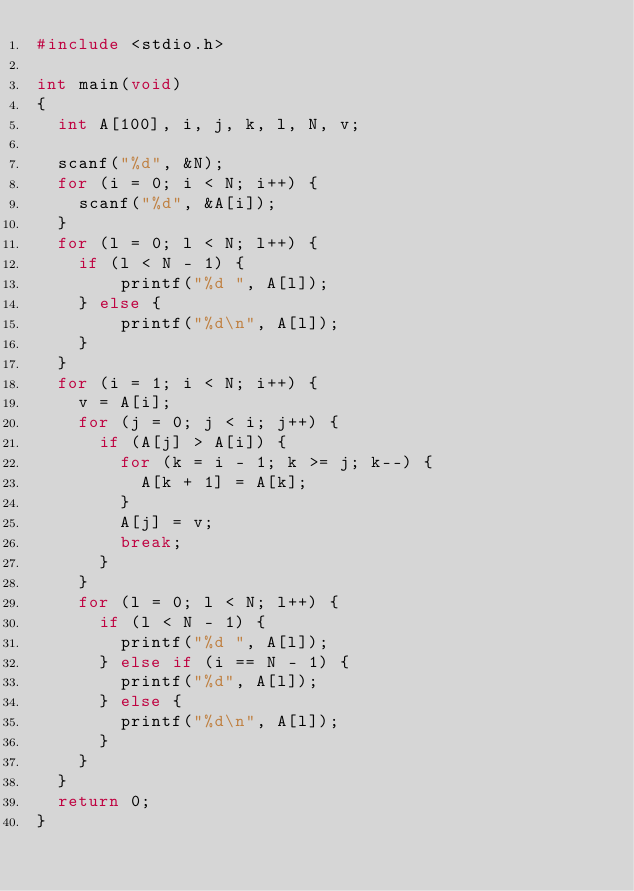Convert code to text. <code><loc_0><loc_0><loc_500><loc_500><_C_>#include <stdio.h>

int main(void)
{
	int A[100], i, j, k, l, N, v;
	
	scanf("%d", &N);
	for (i = 0; i < N; i++) {
		scanf("%d", &A[i]);
	}
	for (l = 0; l < N; l++) {
		if (l < N - 1) {
				printf("%d ", A[l]);
		} else {
				printf("%d\n", A[l]);
		}
	}
	for (i = 1; i < N; i++) {
		v = A[i];
		for (j = 0; j < i; j++) {
			if (A[j] > A[i]) {
				for (k = i - 1; k >= j; k--) {
					A[k + 1] = A[k];
				}
				A[j] = v;
				break;
			}
		}
		for (l = 0; l < N; l++) {
			if (l < N - 1) {
				printf("%d ", A[l]);
			} else if (i == N - 1) {
				printf("%d", A[l]);
			} else {
				printf("%d\n", A[l]);
			}
		}
	}
	return 0;
}</code> 